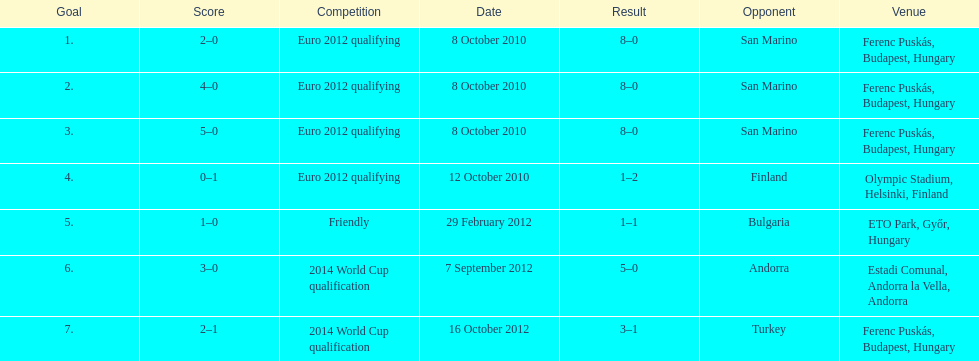Szalai scored only one more international goal against all other countries put together than he did against what one country? San Marino. 